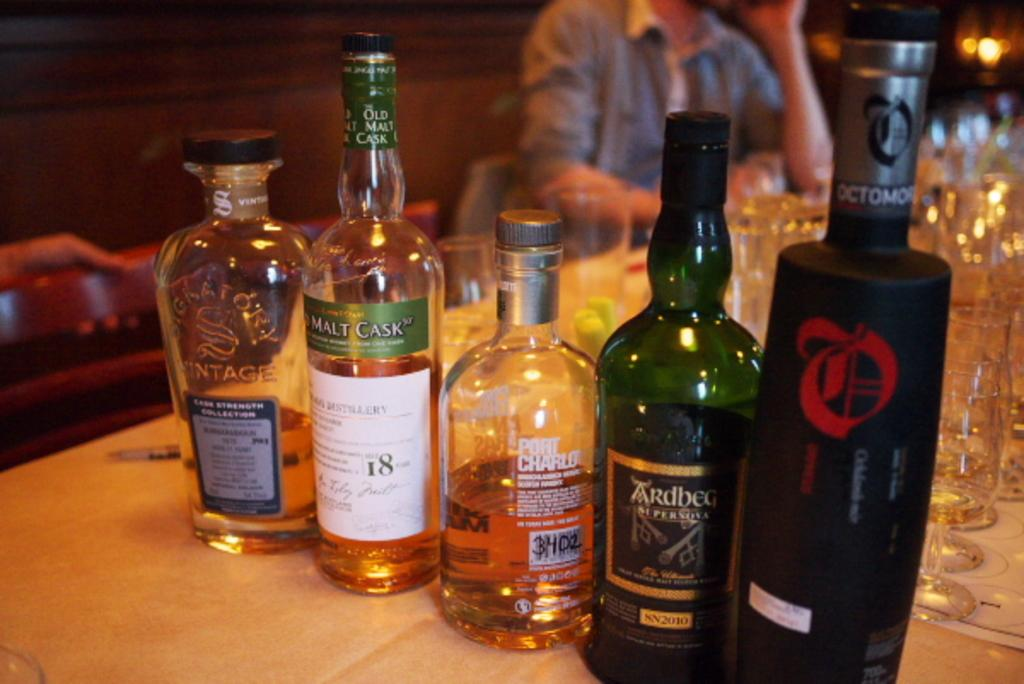<image>
Present a compact description of the photo's key features. a bottle of Port Charlo is next to other bottles 